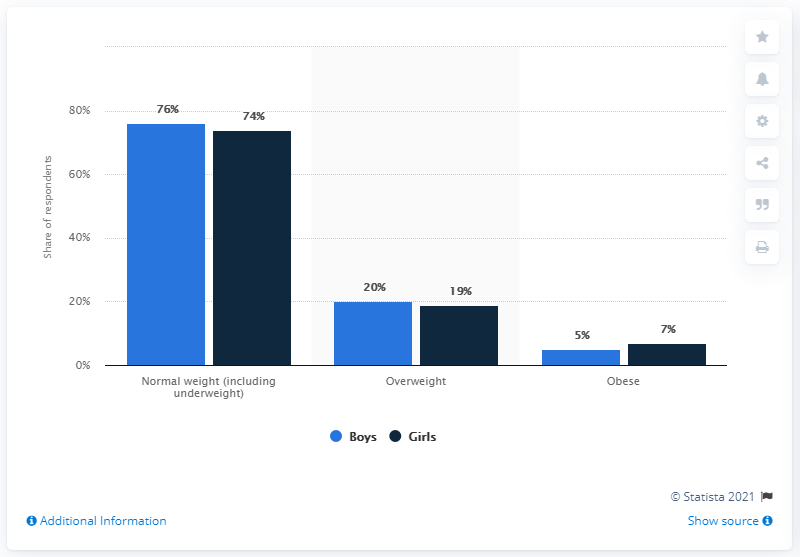Identify some key points in this picture. Obesity is more prevalent among girls than other genders. According to the data, boys are more likely to be overweight than girls by a percentage point. 